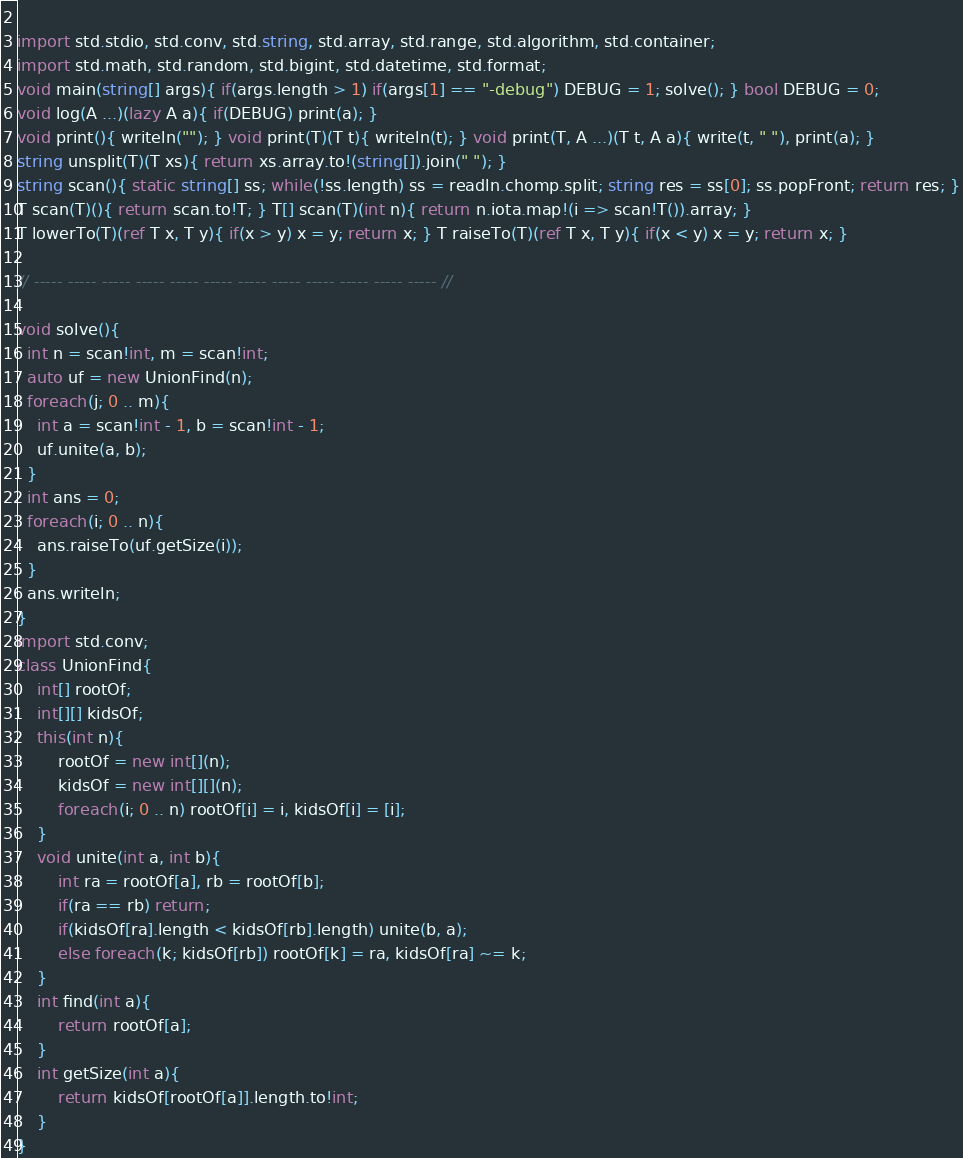Convert code to text. <code><loc_0><loc_0><loc_500><loc_500><_D_> 
import std.stdio, std.conv, std.string, std.array, std.range, std.algorithm, std.container;
import std.math, std.random, std.bigint, std.datetime, std.format;
void main(string[] args){ if(args.length > 1) if(args[1] == "-debug") DEBUG = 1; solve(); } bool DEBUG = 0; 
void log(A ...)(lazy A a){ if(DEBUG) print(a); }
void print(){ writeln(""); } void print(T)(T t){ writeln(t); } void print(T, A ...)(T t, A a){ write(t, " "), print(a); }
string unsplit(T)(T xs){ return xs.array.to!(string[]).join(" "); }
string scan(){ static string[] ss; while(!ss.length) ss = readln.chomp.split; string res = ss[0]; ss.popFront; return res; }
T scan(T)(){ return scan.to!T; } T[] scan(T)(int n){ return n.iota.map!(i => scan!T()).array; }
T lowerTo(T)(ref T x, T y){ if(x > y) x = y; return x; } T raiseTo(T)(ref T x, T y){ if(x < y) x = y; return x; }

// ----- ----- ----- ----- ----- ----- ----- ----- ----- ----- ----- ----- //

void solve(){
  int n = scan!int, m = scan!int;
  auto uf = new UnionFind(n);
  foreach(j; 0 .. m){
    int a = scan!int - 1, b = scan!int - 1;
    uf.unite(a, b);
  }
  int ans = 0;
  foreach(i; 0 .. n){
    ans.raiseTo(uf.getSize(i));
  }
  ans.writeln;
}
import std.conv;
class UnionFind{
    int[] rootOf;
    int[][] kidsOf;
    this(int n){
        rootOf = new int[](n);
        kidsOf = new int[][](n);
        foreach(i; 0 .. n) rootOf[i] = i, kidsOf[i] = [i];
    }
    void unite(int a, int b){
        int ra = rootOf[a], rb = rootOf[b];
        if(ra == rb) return;
        if(kidsOf[ra].length < kidsOf[rb].length) unite(b, a);
        else foreach(k; kidsOf[rb]) rootOf[k] = ra, kidsOf[ra] ~= k;
    }
    int find(int a){
        return rootOf[a];
    }
    int getSize(int a){
        return kidsOf[rootOf[a]].length.to!int;
    }
}</code> 